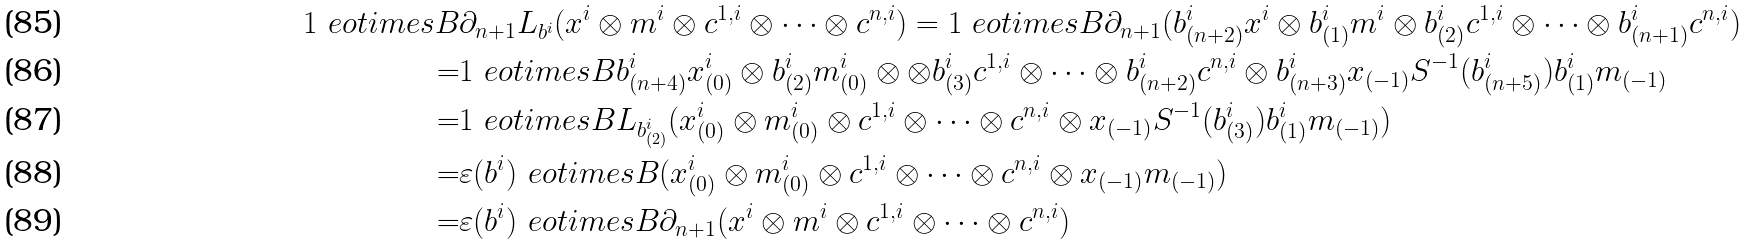<formula> <loc_0><loc_0><loc_500><loc_500>1 \ e o t i m e s { B } & \partial _ { n + 1 } L _ { b ^ { i } } ( x ^ { i } \otimes m ^ { i } \otimes c ^ { 1 , i } \otimes \cdots \otimes c ^ { n , i } ) = 1 \ e o t i m e s { B } \partial _ { n + 1 } ( b ^ { i } _ { ( n + 2 ) } x ^ { i } \otimes b ^ { i } _ { ( 1 ) } m ^ { i } \otimes b ^ { i } _ { ( 2 ) } c ^ { 1 , i } \otimes \cdots \otimes b ^ { i } _ { ( n + 1 ) } c ^ { n , i } ) \\ = & 1 \ e o t i m e s { B } b ^ { i } _ { ( n + 4 ) } x ^ { i } _ { ( 0 ) } \otimes b ^ { i } _ { ( 2 ) } m ^ { i } _ { ( 0 ) } \otimes \otimes b ^ { i } _ { ( 3 ) } c ^ { 1 , i } \otimes \cdots \otimes b ^ { i } _ { ( n + 2 ) } c ^ { n , i } \otimes b ^ { i } _ { ( n + 3 ) } x _ { ( - 1 ) } S ^ { - 1 } ( b ^ { i } _ { ( n + 5 ) } ) b ^ { i } _ { ( 1 ) } m _ { ( - 1 ) } \\ = & 1 \ e o t i m e s { B } L _ { b ^ { i } _ { ( 2 ) } } ( x ^ { i } _ { ( 0 ) } \otimes m ^ { i } _ { ( 0 ) } \otimes c ^ { 1 , i } \otimes \cdots \otimes c ^ { n , i } \otimes x _ { ( - 1 ) } S ^ { - 1 } ( b ^ { i } _ { ( 3 ) } ) b ^ { i } _ { ( 1 ) } m _ { ( - 1 ) } ) \\ = & \varepsilon ( b ^ { i } ) \ e o t i m e s { B } ( x ^ { i } _ { ( 0 ) } \otimes m ^ { i } _ { ( 0 ) } \otimes c ^ { 1 , i } \otimes \cdots \otimes c ^ { n , i } \otimes x _ { ( - 1 ) } m _ { ( - 1 ) } ) \\ = & \varepsilon ( b ^ { i } ) \ e o t i m e s { B } \partial _ { n + 1 } ( x ^ { i } \otimes m ^ { i } \otimes c ^ { 1 , i } \otimes \cdots \otimes c ^ { n , i } )</formula> 